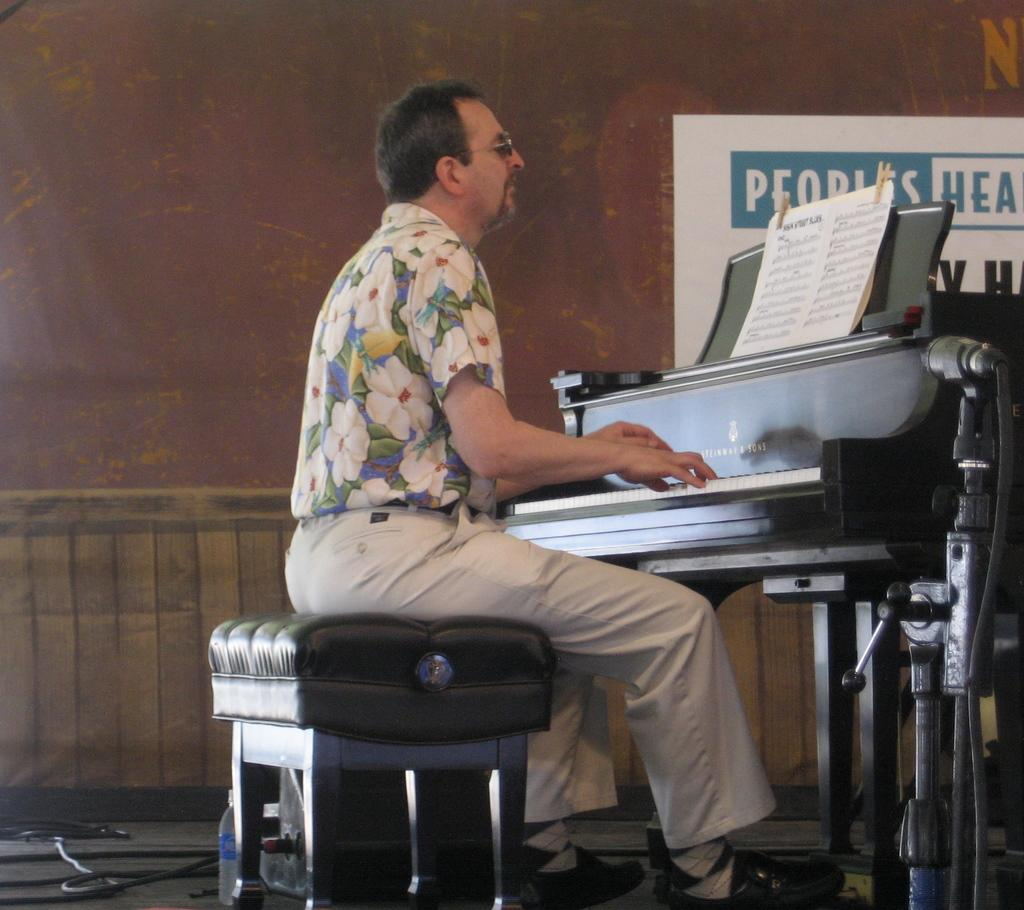Who is the person in the image? There is a man in the image. What is the man doing in the image? The man is sitting on a stool and playing the piano. What instrument is the man playing? The man is playing a piano. What can be seen in front of the man? Musical notes are present in front of the man. What type of tiger can be seen playing baseball in the image? There is no tiger or baseball present in the image; it features a man playing the piano. What is the starting point of the man's performance in the image? The image does not provide information about the starting point of the man's performance, as it only shows him playing the piano. 